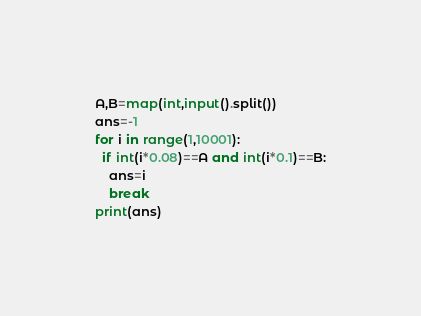Convert code to text. <code><loc_0><loc_0><loc_500><loc_500><_Python_>A,B=map(int,input().split())
ans=-1
for i in range(1,10001):
  if int(i*0.08)==A and int(i*0.1)==B:
    ans=i
    break
print(ans)</code> 